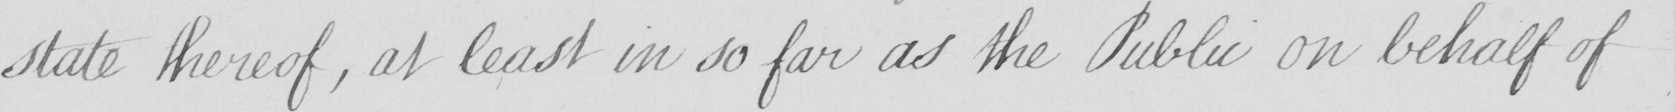Transcribe the text shown in this historical manuscript line. state thereof , at least in so far as the Public on behalf of 